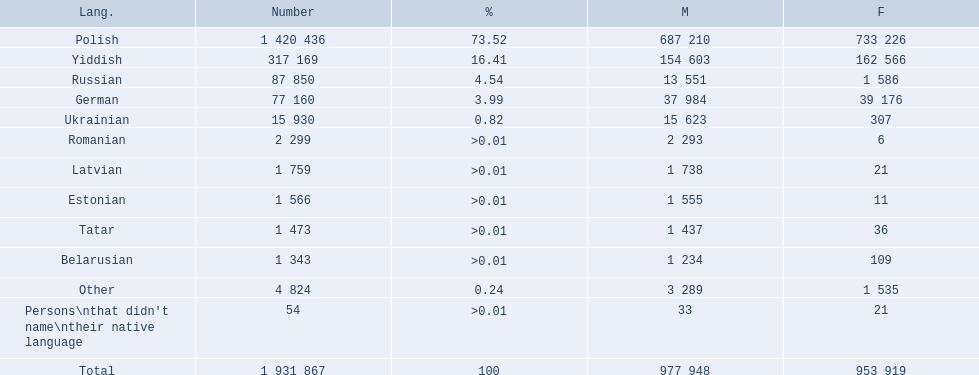How many languages are there? Polish, Yiddish, Russian, German, Ukrainian, Romanian, Latvian, Estonian, Tatar, Belarusian. Which language do more people speak? Polish. 